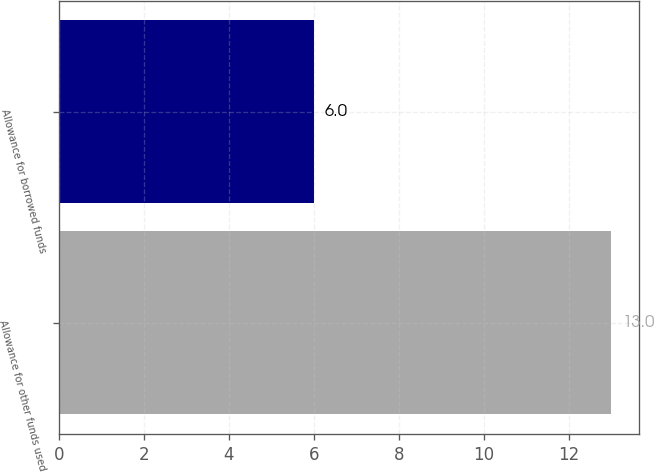<chart> <loc_0><loc_0><loc_500><loc_500><bar_chart><fcel>Allowance for other funds used<fcel>Allowance for borrowed funds<nl><fcel>13<fcel>6<nl></chart> 